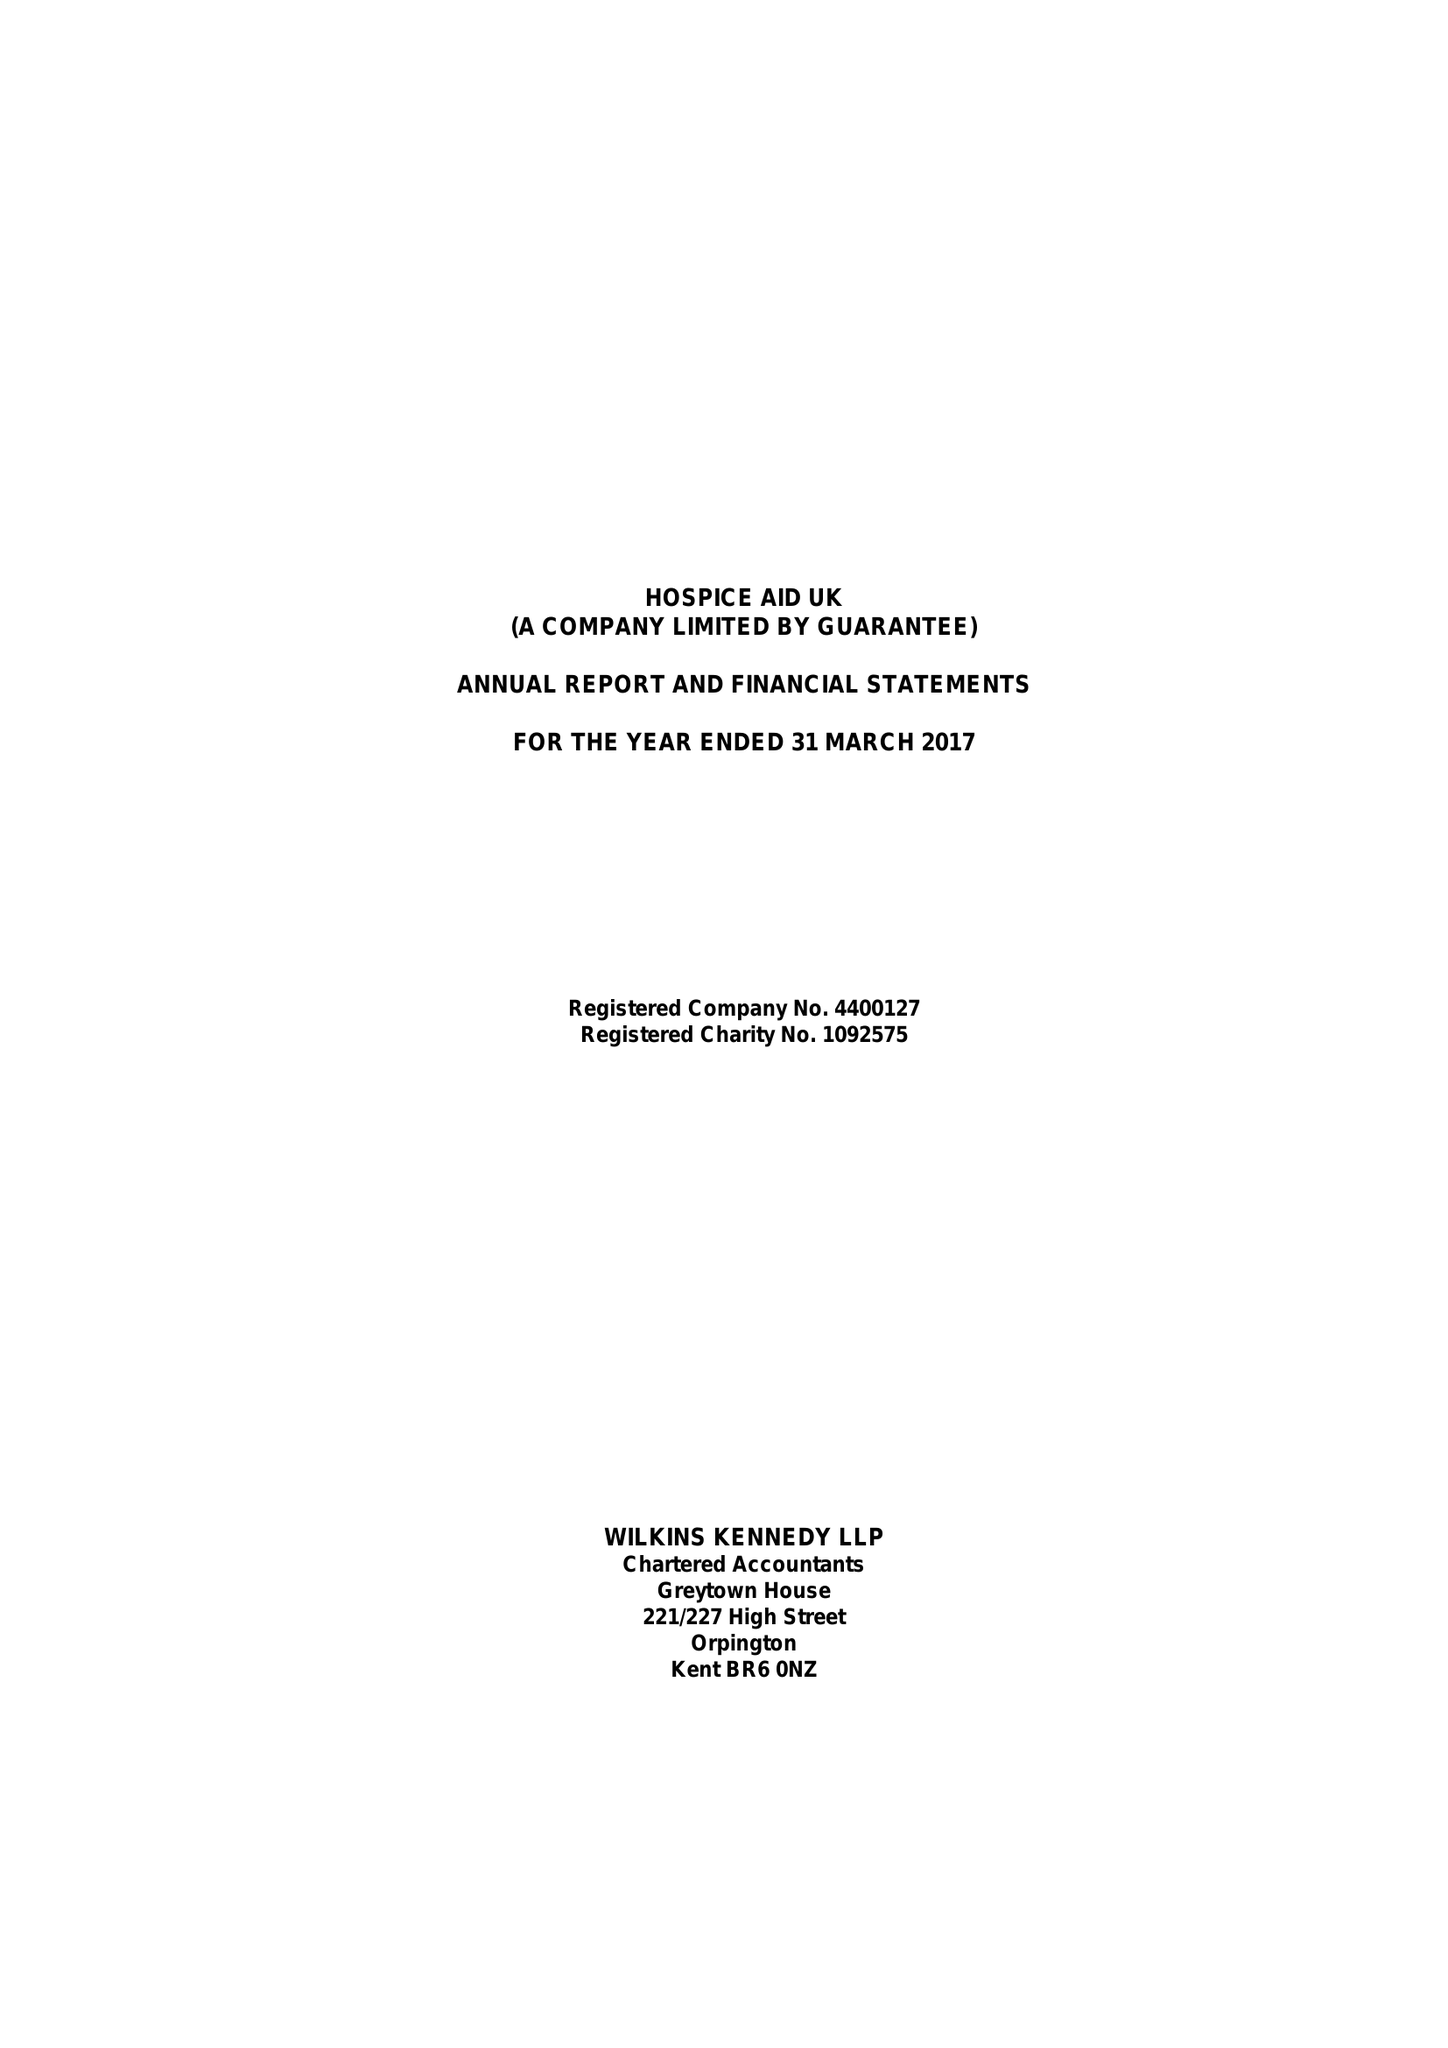What is the value for the charity_number?
Answer the question using a single word or phrase. 1092575 